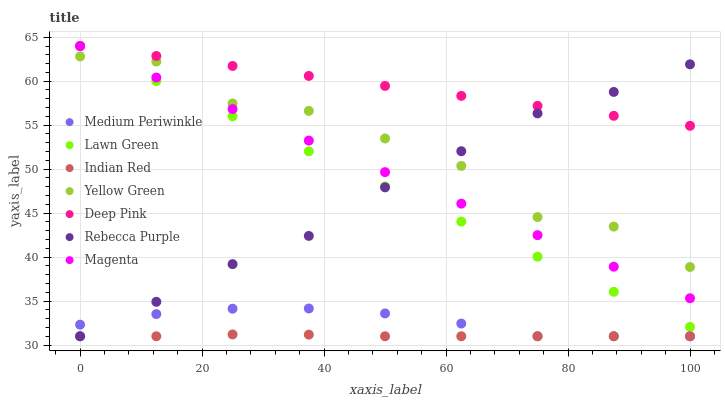Does Indian Red have the minimum area under the curve?
Answer yes or no. Yes. Does Deep Pink have the maximum area under the curve?
Answer yes or no. Yes. Does Yellow Green have the minimum area under the curve?
Answer yes or no. No. Does Yellow Green have the maximum area under the curve?
Answer yes or no. No. Is Lawn Green the smoothest?
Answer yes or no. Yes. Is Yellow Green the roughest?
Answer yes or no. Yes. Is Deep Pink the smoothest?
Answer yes or no. No. Is Deep Pink the roughest?
Answer yes or no. No. Does Medium Periwinkle have the lowest value?
Answer yes or no. Yes. Does Yellow Green have the lowest value?
Answer yes or no. No. Does Magenta have the highest value?
Answer yes or no. Yes. Does Yellow Green have the highest value?
Answer yes or no. No. Is Indian Red less than Magenta?
Answer yes or no. Yes. Is Lawn Green greater than Indian Red?
Answer yes or no. Yes. Does Lawn Green intersect Rebecca Purple?
Answer yes or no. Yes. Is Lawn Green less than Rebecca Purple?
Answer yes or no. No. Is Lawn Green greater than Rebecca Purple?
Answer yes or no. No. Does Indian Red intersect Magenta?
Answer yes or no. No. 